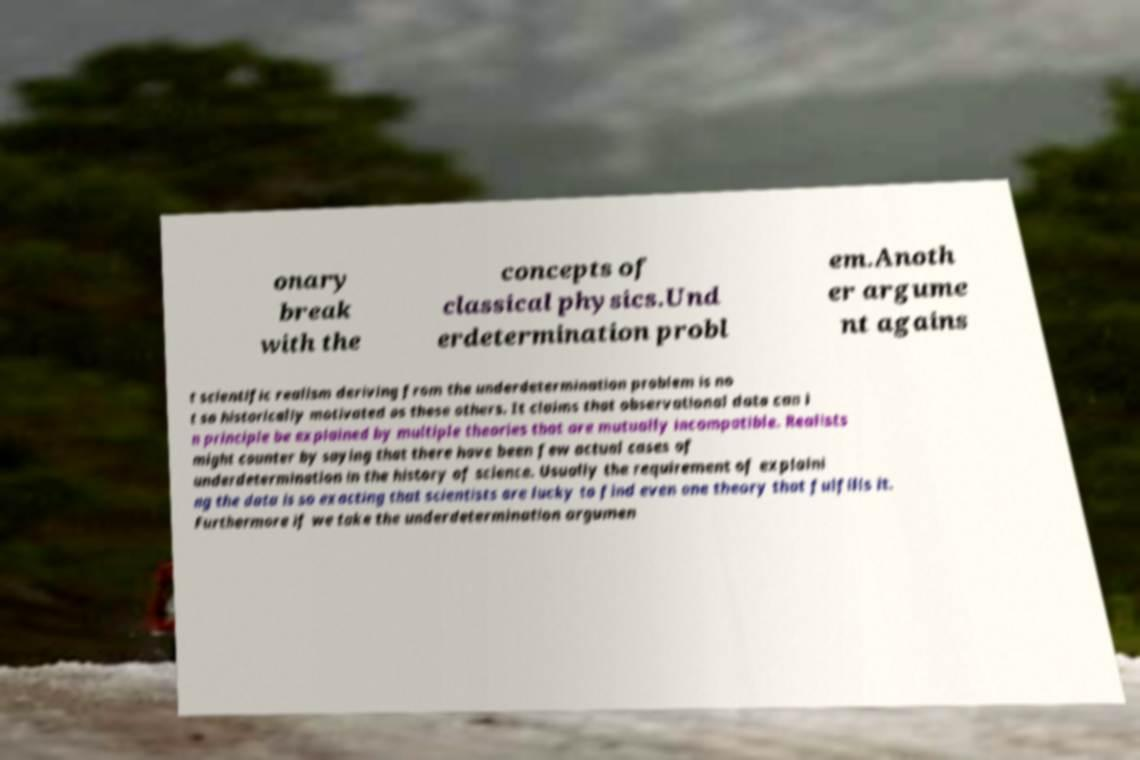Can you read and provide the text displayed in the image?This photo seems to have some interesting text. Can you extract and type it out for me? onary break with the concepts of classical physics.Und erdetermination probl em.Anoth er argume nt agains t scientific realism deriving from the underdetermination problem is no t so historically motivated as these others. It claims that observational data can i n principle be explained by multiple theories that are mutually incompatible. Realists might counter by saying that there have been few actual cases of underdetermination in the history of science. Usually the requirement of explaini ng the data is so exacting that scientists are lucky to find even one theory that fulfills it. Furthermore if we take the underdetermination argumen 